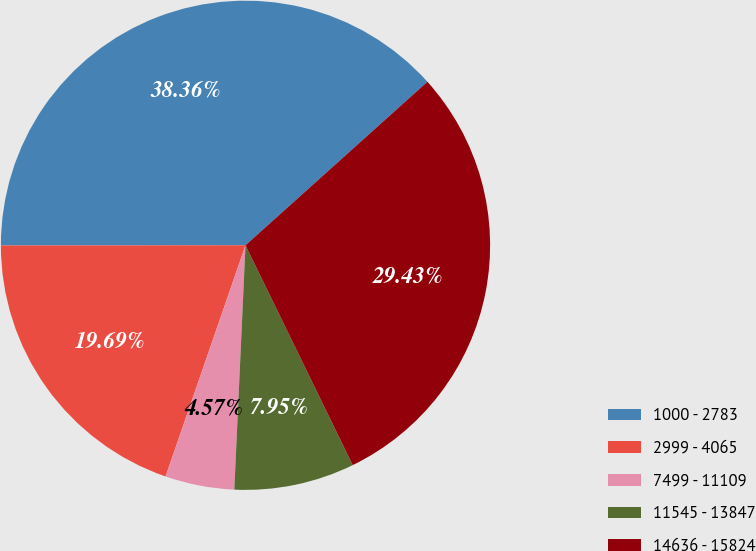Convert chart to OTSL. <chart><loc_0><loc_0><loc_500><loc_500><pie_chart><fcel>1000 - 2783<fcel>2999 - 4065<fcel>7499 - 11109<fcel>11545 - 13847<fcel>14636 - 15824<nl><fcel>38.36%<fcel>19.69%<fcel>4.57%<fcel>7.95%<fcel>29.43%<nl></chart> 